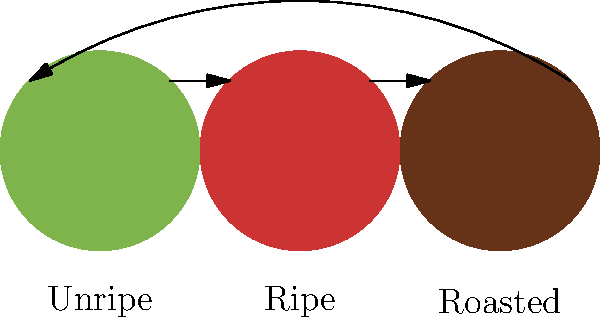Consider a color palette derived from three stages of coffee plant development: unripe (green), ripe (red), and roasted (brown). If we apply a cyclic permutation group $C_3$ to this palette, how many distinct arrangements of these colors are possible under the group action? To solve this problem, we need to follow these steps:

1. Understand the group action:
   The cyclic permutation group $C_3$ acts on the set of three colors by rotating them.

2. Identify the orbit:
   The orbit of any color under this group action includes all three colors because repeated application of the cyclic permutation will eventually reach all colors.

3. Calculate the number of distinct arrangements:
   In group theory, the number of distinct arrangements under a group action is equal to the number of orbits.

4. Apply the Orbit-Stabilizer theorem:
   The Orbit-Stabilizer theorem states that $|G| = |Orbit(x)| \cdot |Stab(x)|$
   Where $|G|$ is the order of the group, $|Orbit(x)|$ is the size of the orbit of any element $x$, and $|Stab(x)|$ is the size of the stabilizer of $x$.

5. Use the theorem:
   We know that $|G| = 3$ (the order of $C_3$), and $|Orbit(x)| = 3$ (as we found in step 2).
   Therefore, $3 = 3 \cdot |Stab(x)|$
   This means $|Stab(x)| = 1$

6. Interpret the result:
   The fact that the stabilizer has size 1 means that each arrangement is unique under the group action.

7. Conclude:
   Since there is only one orbit and each element in the orbit represents a unique arrangement, there is only one distinct arrangement under this group action.
Answer: 1 